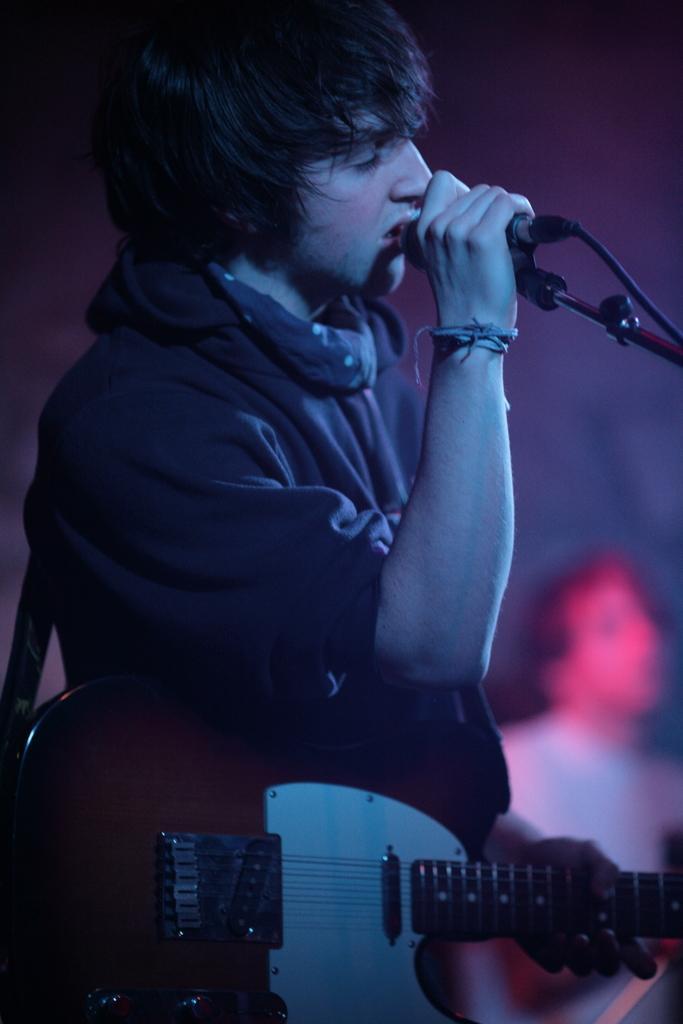In one or two sentences, can you explain what this image depicts? In this image there is a person holding microphone and he is holding guitar with his left hand. At the back there is another person. 